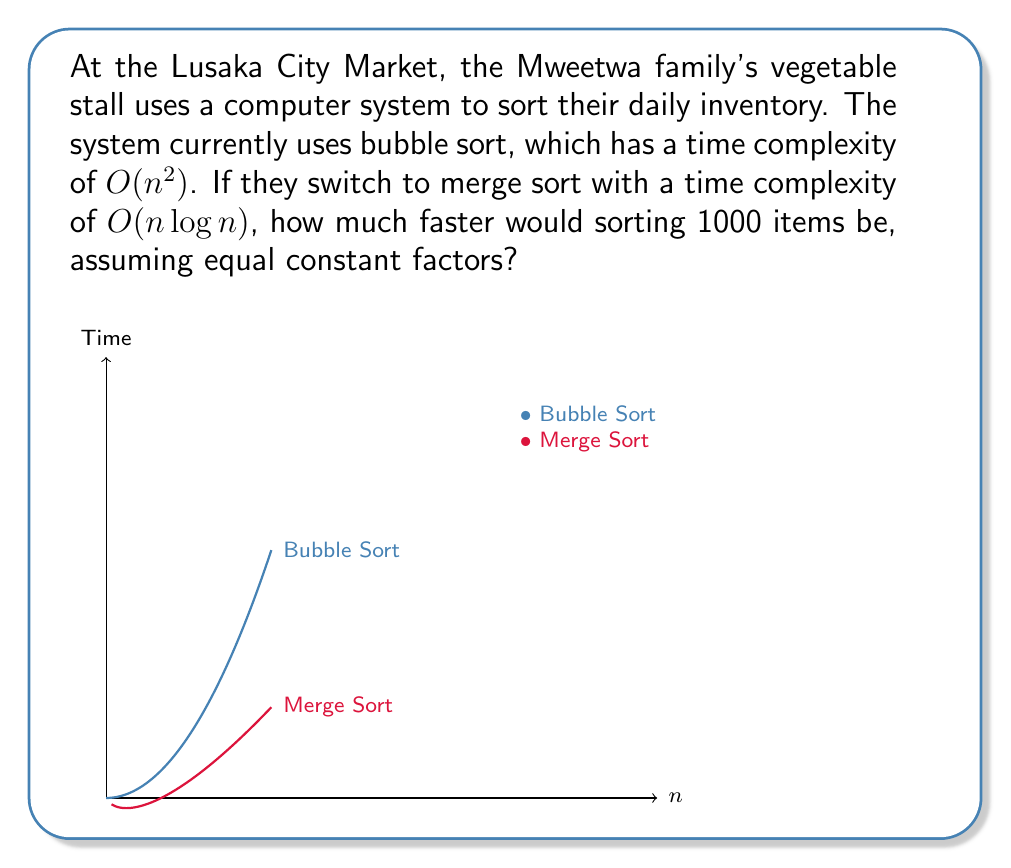Teach me how to tackle this problem. Let's approach this step-by-step:

1) Bubble sort time complexity: $T_1(n) = O(n^2)$
   Merge sort time complexity: $T_2(n) = O(n \log n)$

2) For $n = 1000$ items:
   $T_1(1000) = 1000^2 = 1,000,000$
   $T_2(1000) = 1000 \log_2 1000 \approx 9,966$

3) To find how much faster merge sort is, we calculate the ratio:

   $$\frac{T_1(1000)}{T_2(1000)} = \frac{1,000,000}{9,966} \approx 100.34$$

4) This means merge sort is approximately 100.34 times faster for 1000 items.

5) To express this as a percentage improvement:
   
   $$\text{Improvement} = \frac{T_1(1000) - T_2(1000)}{T_1(1000)} \times 100\%$$
   $$= \frac{1,000,000 - 9,966}{1,000,000} \times 100\% \approx 99.00\%$$

Therefore, switching to merge sort would make the sorting process approximately 100 times faster, or improve the speed by about 99%.
Answer: Approximately 100 times faster, or 99% improvement. 